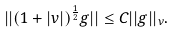<formula> <loc_0><loc_0><loc_500><loc_500>| | ( 1 + | v | ) ^ { \frac { 1 } { 2 } } g | | \leq C | | g | | _ { \nu } .</formula> 